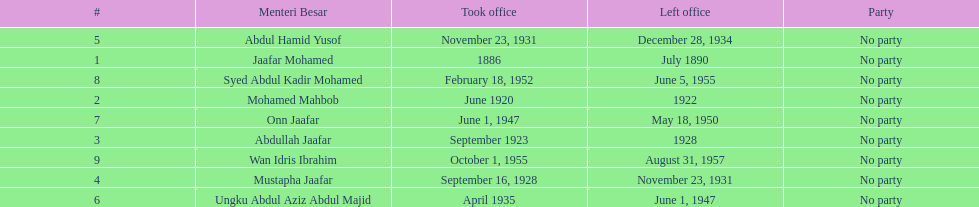Who was the first to take office? Jaafar Mohamed. 